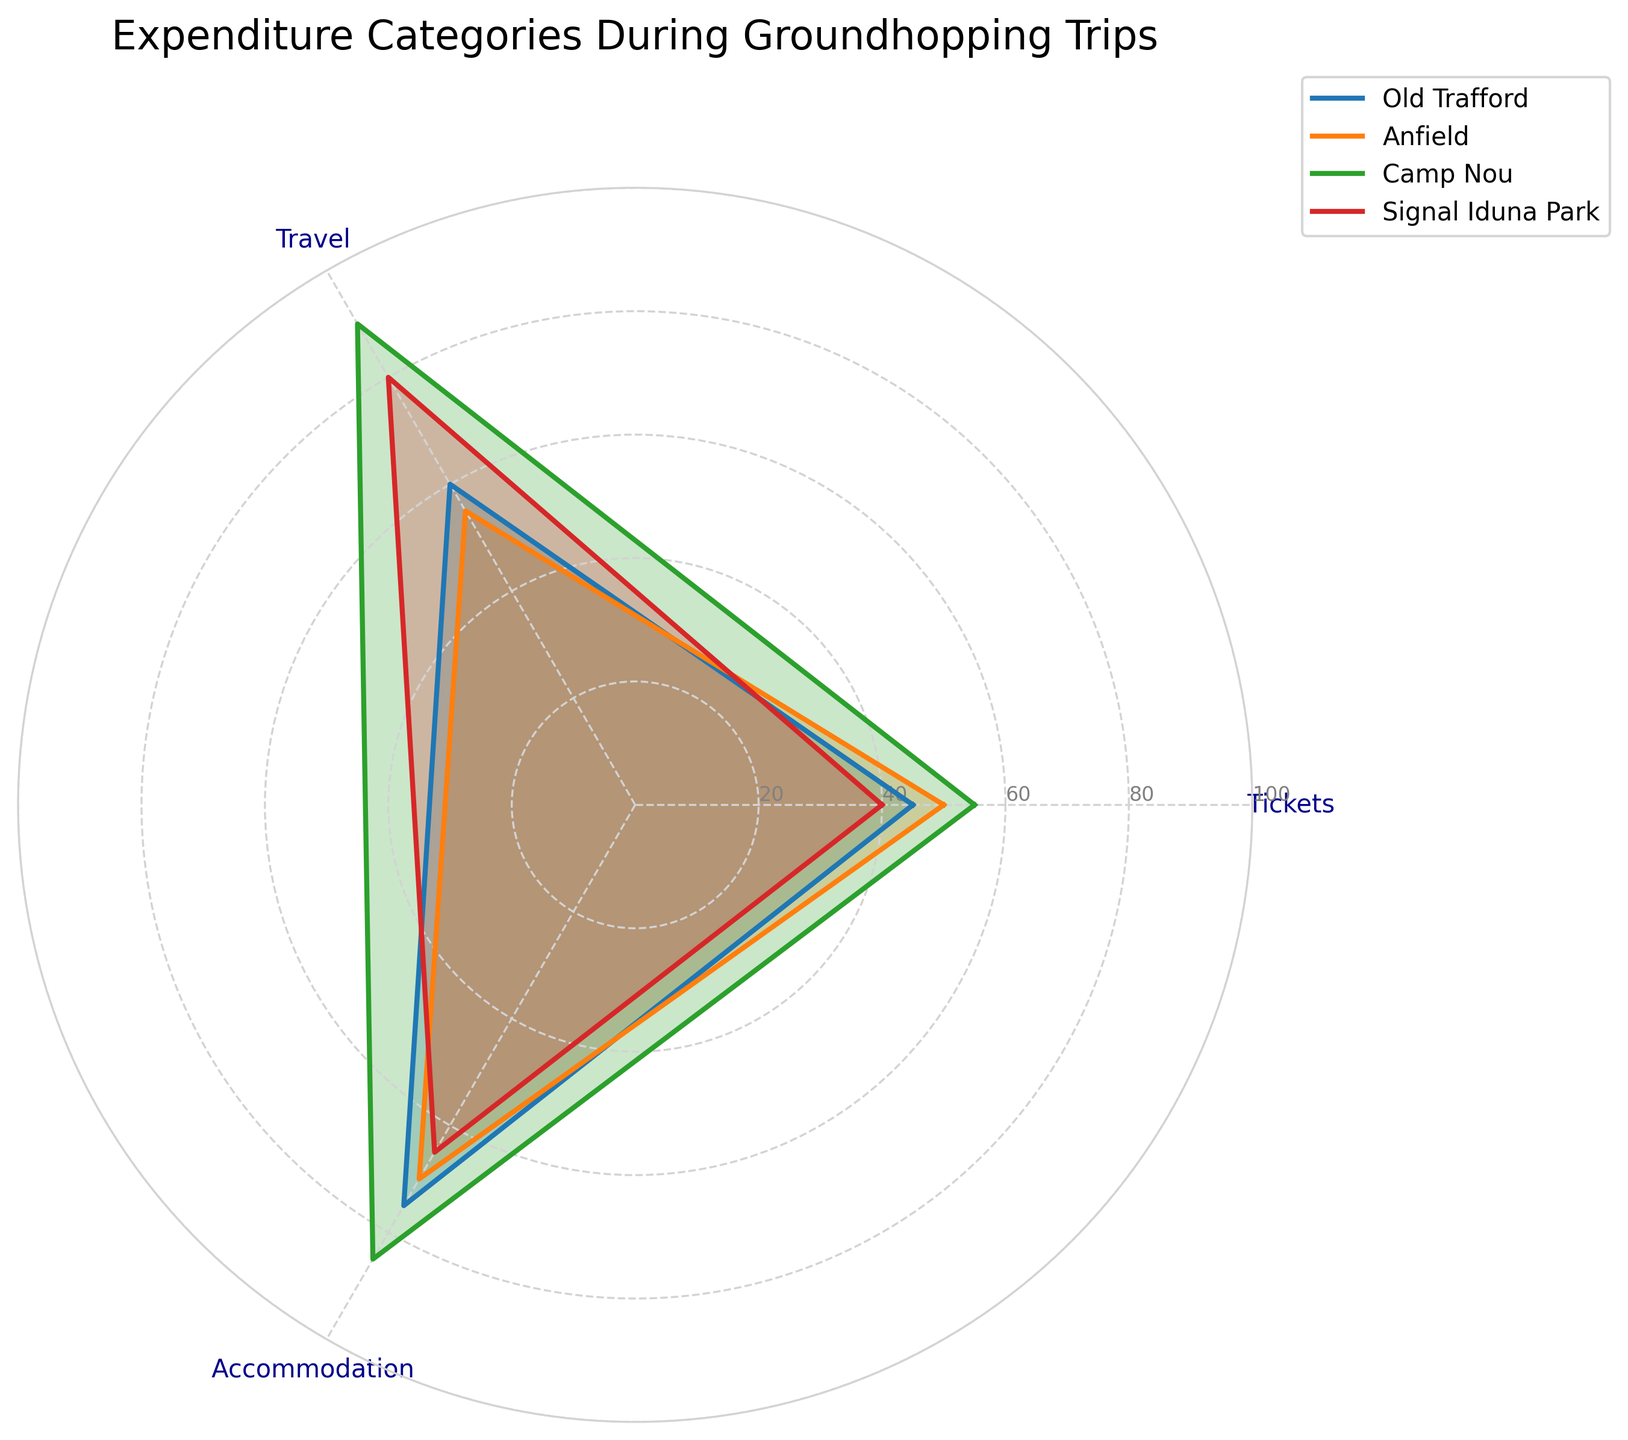What are the expenditure categories listed in the radar chart? The radar chart shows three expenditure categories for groundhopping trips: Tickets, Travel, and Accommodation.
Answer: Tickets, Travel, Accommodation Which stadium has the highest expenditure on travel? To find the stadium with the highest expenditure on travel, look at the Travel category for each stadium. Camp Nou has the highest value at 90.
Answer: Camp Nou Compare the accommodation expenses between Old Trafford and Signal Iduna Park. Which one is higher? Look at the Accommodation category for both Old Trafford (75) and Signal Iduna Park (65). Old Trafford has higher accommodation expenses.
Answer: Old Trafford What is the average expenditure on tickets across all stadiums? The expenditures on tickets are Old Trafford (45), Anfield (50), Camp Nou (55), and Signal Iduna Park (40). The average is calculated as (45 + 50 + 55 + 40) / 4 = 47.5.
Answer: 47.5 Which stadium has the lowest overall expenditure when considering all three categories? The overall expenditure can be found by summing the values for Tickets, Travel, and Accommodation for each stadium and comparing them. Old Trafford: (45 + 60 + 75) = 180, Anfield: (50 + 55 + 70) = 175, Camp Nou: (55 + 90 + 85) = 230, Signal Iduna Park: (40 + 80 + 65) = 185. Anfield has the lowest overall expenditure.
Answer: Anfield Are the expenses on accommodation at Camp Nou the highest among all the categorized expenses for any stadium? Check all the values in the Accommodation category and compare them to other expenses. Camp Nou has 85 for Accommodation, which is not higher than its Travel expense of 90. Therefore, Camp Nou's expenditure on Accommodation is not the highest among all categorized expenses.
Answer: No Is there a trend where a stadium with higher ticket prices also has higher accommodation costs? Compare the expenditures on Tickets and Accommodation for each stadium. Old Trafford: 45 (Tickets), 75 (Accommodation); Anfield: 50 (Tickets), 70 (Accommodation); Camp Nou: 55 (Tickets), 85 (Accommodation); Signal Iduna Park: 40 (Tickets), 65 (Accommodation). Higher ticket prices do not consistently correspond with higher accommodation costs.
Answer: No By how much does Camp Nou's expenditure on travel exceed Old Trafford's? Subtract Old Trafford's travel expenditure (60) from Camp Nou's (90). The difference is 90 - 60 = 30.
Answer: 30 